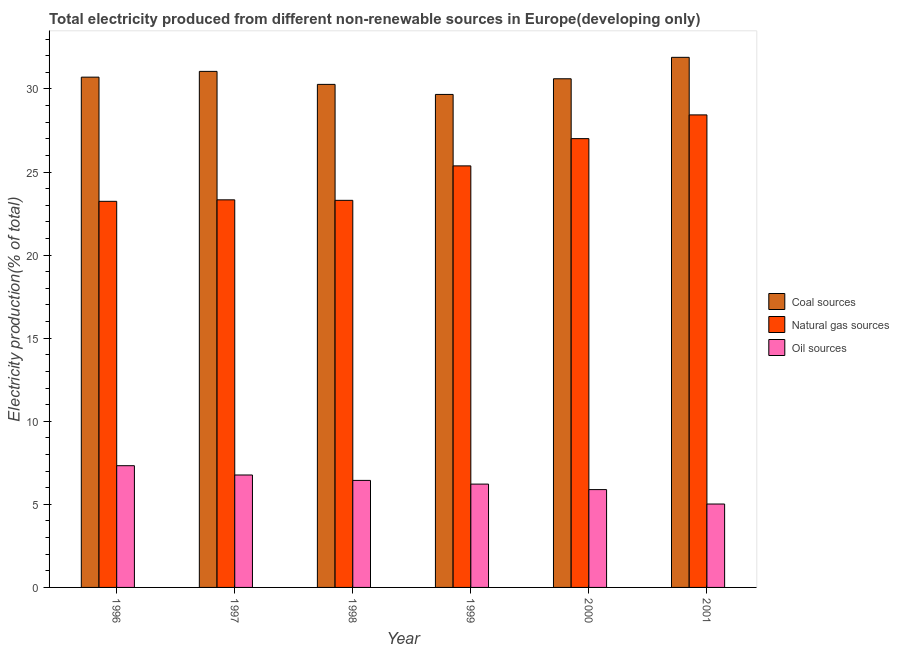How many groups of bars are there?
Your answer should be compact. 6. Are the number of bars on each tick of the X-axis equal?
Keep it short and to the point. Yes. How many bars are there on the 2nd tick from the left?
Provide a short and direct response. 3. How many bars are there on the 4th tick from the right?
Your answer should be compact. 3. What is the percentage of electricity produced by oil sources in 1998?
Your answer should be compact. 6.44. Across all years, what is the maximum percentage of electricity produced by coal?
Ensure brevity in your answer.  31.9. Across all years, what is the minimum percentage of electricity produced by coal?
Provide a succinct answer. 29.67. What is the total percentage of electricity produced by natural gas in the graph?
Your answer should be compact. 150.68. What is the difference between the percentage of electricity produced by oil sources in 1999 and that in 2001?
Your answer should be compact. 1.2. What is the difference between the percentage of electricity produced by coal in 2000 and the percentage of electricity produced by natural gas in 2001?
Offer a very short reply. -1.29. What is the average percentage of electricity produced by coal per year?
Keep it short and to the point. 30.71. In the year 2001, what is the difference between the percentage of electricity produced by coal and percentage of electricity produced by oil sources?
Make the answer very short. 0. In how many years, is the percentage of electricity produced by natural gas greater than 8 %?
Your answer should be very brief. 6. What is the ratio of the percentage of electricity produced by natural gas in 1998 to that in 1999?
Offer a terse response. 0.92. Is the percentage of electricity produced by coal in 1997 less than that in 1999?
Your answer should be compact. No. What is the difference between the highest and the second highest percentage of electricity produced by oil sources?
Your answer should be very brief. 0.56. What is the difference between the highest and the lowest percentage of electricity produced by coal?
Offer a very short reply. 2.23. In how many years, is the percentage of electricity produced by oil sources greater than the average percentage of electricity produced by oil sources taken over all years?
Offer a terse response. 3. Is the sum of the percentage of electricity produced by oil sources in 2000 and 2001 greater than the maximum percentage of electricity produced by natural gas across all years?
Keep it short and to the point. Yes. What does the 1st bar from the left in 1998 represents?
Offer a terse response. Coal sources. What does the 2nd bar from the right in 1999 represents?
Provide a short and direct response. Natural gas sources. Is it the case that in every year, the sum of the percentage of electricity produced by coal and percentage of electricity produced by natural gas is greater than the percentage of electricity produced by oil sources?
Make the answer very short. Yes. Are all the bars in the graph horizontal?
Provide a succinct answer. No. Does the graph contain any zero values?
Ensure brevity in your answer.  No. What is the title of the graph?
Give a very brief answer. Total electricity produced from different non-renewable sources in Europe(developing only). Does "ICT services" appear as one of the legend labels in the graph?
Your response must be concise. No. What is the label or title of the Y-axis?
Keep it short and to the point. Electricity production(% of total). What is the Electricity production(% of total) of Coal sources in 1996?
Your response must be concise. 30.71. What is the Electricity production(% of total) in Natural gas sources in 1996?
Your response must be concise. 23.24. What is the Electricity production(% of total) of Oil sources in 1996?
Ensure brevity in your answer.  7.33. What is the Electricity production(% of total) of Coal sources in 1997?
Ensure brevity in your answer.  31.06. What is the Electricity production(% of total) in Natural gas sources in 1997?
Provide a short and direct response. 23.33. What is the Electricity production(% of total) of Oil sources in 1997?
Give a very brief answer. 6.77. What is the Electricity production(% of total) of Coal sources in 1998?
Offer a very short reply. 30.28. What is the Electricity production(% of total) in Natural gas sources in 1998?
Keep it short and to the point. 23.3. What is the Electricity production(% of total) in Oil sources in 1998?
Ensure brevity in your answer.  6.44. What is the Electricity production(% of total) of Coal sources in 1999?
Make the answer very short. 29.67. What is the Electricity production(% of total) in Natural gas sources in 1999?
Give a very brief answer. 25.37. What is the Electricity production(% of total) in Oil sources in 1999?
Your answer should be very brief. 6.22. What is the Electricity production(% of total) of Coal sources in 2000?
Keep it short and to the point. 30.61. What is the Electricity production(% of total) in Natural gas sources in 2000?
Make the answer very short. 27.01. What is the Electricity production(% of total) of Oil sources in 2000?
Your response must be concise. 5.89. What is the Electricity production(% of total) in Coal sources in 2001?
Offer a very short reply. 31.9. What is the Electricity production(% of total) in Natural gas sources in 2001?
Keep it short and to the point. 28.44. What is the Electricity production(% of total) in Oil sources in 2001?
Your answer should be very brief. 5.02. Across all years, what is the maximum Electricity production(% of total) of Coal sources?
Provide a succinct answer. 31.9. Across all years, what is the maximum Electricity production(% of total) in Natural gas sources?
Provide a short and direct response. 28.44. Across all years, what is the maximum Electricity production(% of total) of Oil sources?
Ensure brevity in your answer.  7.33. Across all years, what is the minimum Electricity production(% of total) of Coal sources?
Give a very brief answer. 29.67. Across all years, what is the minimum Electricity production(% of total) of Natural gas sources?
Ensure brevity in your answer.  23.24. Across all years, what is the minimum Electricity production(% of total) of Oil sources?
Give a very brief answer. 5.02. What is the total Electricity production(% of total) of Coal sources in the graph?
Your answer should be compact. 184.23. What is the total Electricity production(% of total) in Natural gas sources in the graph?
Provide a short and direct response. 150.68. What is the total Electricity production(% of total) of Oil sources in the graph?
Offer a very short reply. 37.66. What is the difference between the Electricity production(% of total) in Coal sources in 1996 and that in 1997?
Make the answer very short. -0.35. What is the difference between the Electricity production(% of total) in Natural gas sources in 1996 and that in 1997?
Provide a short and direct response. -0.09. What is the difference between the Electricity production(% of total) of Oil sources in 1996 and that in 1997?
Your response must be concise. 0.56. What is the difference between the Electricity production(% of total) in Coal sources in 1996 and that in 1998?
Offer a very short reply. 0.44. What is the difference between the Electricity production(% of total) in Natural gas sources in 1996 and that in 1998?
Offer a very short reply. -0.06. What is the difference between the Electricity production(% of total) in Oil sources in 1996 and that in 1998?
Provide a short and direct response. 0.88. What is the difference between the Electricity production(% of total) of Coal sources in 1996 and that in 1999?
Your answer should be very brief. 1.04. What is the difference between the Electricity production(% of total) of Natural gas sources in 1996 and that in 1999?
Provide a succinct answer. -2.13. What is the difference between the Electricity production(% of total) in Oil sources in 1996 and that in 1999?
Give a very brief answer. 1.11. What is the difference between the Electricity production(% of total) of Coal sources in 1996 and that in 2000?
Your response must be concise. 0.1. What is the difference between the Electricity production(% of total) of Natural gas sources in 1996 and that in 2000?
Your answer should be very brief. -3.77. What is the difference between the Electricity production(% of total) in Oil sources in 1996 and that in 2000?
Your answer should be compact. 1.44. What is the difference between the Electricity production(% of total) in Coal sources in 1996 and that in 2001?
Offer a terse response. -1.19. What is the difference between the Electricity production(% of total) in Natural gas sources in 1996 and that in 2001?
Your response must be concise. -5.2. What is the difference between the Electricity production(% of total) of Oil sources in 1996 and that in 2001?
Your response must be concise. 2.31. What is the difference between the Electricity production(% of total) in Coal sources in 1997 and that in 1998?
Offer a terse response. 0.78. What is the difference between the Electricity production(% of total) of Natural gas sources in 1997 and that in 1998?
Your answer should be compact. 0.03. What is the difference between the Electricity production(% of total) of Oil sources in 1997 and that in 1998?
Give a very brief answer. 0.33. What is the difference between the Electricity production(% of total) in Coal sources in 1997 and that in 1999?
Provide a succinct answer. 1.39. What is the difference between the Electricity production(% of total) in Natural gas sources in 1997 and that in 1999?
Keep it short and to the point. -2.04. What is the difference between the Electricity production(% of total) in Oil sources in 1997 and that in 1999?
Ensure brevity in your answer.  0.55. What is the difference between the Electricity production(% of total) of Coal sources in 1997 and that in 2000?
Your response must be concise. 0.45. What is the difference between the Electricity production(% of total) in Natural gas sources in 1997 and that in 2000?
Ensure brevity in your answer.  -3.68. What is the difference between the Electricity production(% of total) of Coal sources in 1997 and that in 2001?
Your response must be concise. -0.85. What is the difference between the Electricity production(% of total) in Natural gas sources in 1997 and that in 2001?
Give a very brief answer. -5.11. What is the difference between the Electricity production(% of total) in Oil sources in 1997 and that in 2001?
Provide a short and direct response. 1.75. What is the difference between the Electricity production(% of total) of Coal sources in 1998 and that in 1999?
Your answer should be very brief. 0.61. What is the difference between the Electricity production(% of total) of Natural gas sources in 1998 and that in 1999?
Your answer should be compact. -2.07. What is the difference between the Electricity production(% of total) in Oil sources in 1998 and that in 1999?
Offer a terse response. 0.22. What is the difference between the Electricity production(% of total) in Coal sources in 1998 and that in 2000?
Keep it short and to the point. -0.34. What is the difference between the Electricity production(% of total) of Natural gas sources in 1998 and that in 2000?
Your response must be concise. -3.71. What is the difference between the Electricity production(% of total) in Oil sources in 1998 and that in 2000?
Offer a very short reply. 0.55. What is the difference between the Electricity production(% of total) of Coal sources in 1998 and that in 2001?
Provide a short and direct response. -1.63. What is the difference between the Electricity production(% of total) of Natural gas sources in 1998 and that in 2001?
Make the answer very short. -5.14. What is the difference between the Electricity production(% of total) in Oil sources in 1998 and that in 2001?
Offer a terse response. 1.42. What is the difference between the Electricity production(% of total) in Coal sources in 1999 and that in 2000?
Your response must be concise. -0.94. What is the difference between the Electricity production(% of total) in Natural gas sources in 1999 and that in 2000?
Your response must be concise. -1.64. What is the difference between the Electricity production(% of total) in Oil sources in 1999 and that in 2000?
Offer a very short reply. 0.33. What is the difference between the Electricity production(% of total) of Coal sources in 1999 and that in 2001?
Provide a succinct answer. -2.23. What is the difference between the Electricity production(% of total) in Natural gas sources in 1999 and that in 2001?
Give a very brief answer. -3.07. What is the difference between the Electricity production(% of total) in Oil sources in 1999 and that in 2001?
Offer a terse response. 1.2. What is the difference between the Electricity production(% of total) in Coal sources in 2000 and that in 2001?
Offer a terse response. -1.29. What is the difference between the Electricity production(% of total) in Natural gas sources in 2000 and that in 2001?
Provide a short and direct response. -1.43. What is the difference between the Electricity production(% of total) in Oil sources in 2000 and that in 2001?
Ensure brevity in your answer.  0.87. What is the difference between the Electricity production(% of total) of Coal sources in 1996 and the Electricity production(% of total) of Natural gas sources in 1997?
Offer a terse response. 7.38. What is the difference between the Electricity production(% of total) of Coal sources in 1996 and the Electricity production(% of total) of Oil sources in 1997?
Your response must be concise. 23.94. What is the difference between the Electricity production(% of total) in Natural gas sources in 1996 and the Electricity production(% of total) in Oil sources in 1997?
Provide a succinct answer. 16.47. What is the difference between the Electricity production(% of total) in Coal sources in 1996 and the Electricity production(% of total) in Natural gas sources in 1998?
Ensure brevity in your answer.  7.41. What is the difference between the Electricity production(% of total) in Coal sources in 1996 and the Electricity production(% of total) in Oil sources in 1998?
Offer a very short reply. 24.27. What is the difference between the Electricity production(% of total) of Natural gas sources in 1996 and the Electricity production(% of total) of Oil sources in 1998?
Your response must be concise. 16.8. What is the difference between the Electricity production(% of total) of Coal sources in 1996 and the Electricity production(% of total) of Natural gas sources in 1999?
Give a very brief answer. 5.34. What is the difference between the Electricity production(% of total) of Coal sources in 1996 and the Electricity production(% of total) of Oil sources in 1999?
Offer a very short reply. 24.49. What is the difference between the Electricity production(% of total) in Natural gas sources in 1996 and the Electricity production(% of total) in Oil sources in 1999?
Your response must be concise. 17.02. What is the difference between the Electricity production(% of total) in Coal sources in 1996 and the Electricity production(% of total) in Natural gas sources in 2000?
Ensure brevity in your answer.  3.7. What is the difference between the Electricity production(% of total) of Coal sources in 1996 and the Electricity production(% of total) of Oil sources in 2000?
Give a very brief answer. 24.82. What is the difference between the Electricity production(% of total) in Natural gas sources in 1996 and the Electricity production(% of total) in Oil sources in 2000?
Provide a succinct answer. 17.35. What is the difference between the Electricity production(% of total) of Coal sources in 1996 and the Electricity production(% of total) of Natural gas sources in 2001?
Your response must be concise. 2.27. What is the difference between the Electricity production(% of total) in Coal sources in 1996 and the Electricity production(% of total) in Oil sources in 2001?
Give a very brief answer. 25.69. What is the difference between the Electricity production(% of total) of Natural gas sources in 1996 and the Electricity production(% of total) of Oil sources in 2001?
Keep it short and to the point. 18.22. What is the difference between the Electricity production(% of total) of Coal sources in 1997 and the Electricity production(% of total) of Natural gas sources in 1998?
Offer a terse response. 7.76. What is the difference between the Electricity production(% of total) in Coal sources in 1997 and the Electricity production(% of total) in Oil sources in 1998?
Your response must be concise. 24.62. What is the difference between the Electricity production(% of total) of Natural gas sources in 1997 and the Electricity production(% of total) of Oil sources in 1998?
Your response must be concise. 16.89. What is the difference between the Electricity production(% of total) in Coal sources in 1997 and the Electricity production(% of total) in Natural gas sources in 1999?
Provide a short and direct response. 5.69. What is the difference between the Electricity production(% of total) in Coal sources in 1997 and the Electricity production(% of total) in Oil sources in 1999?
Offer a terse response. 24.84. What is the difference between the Electricity production(% of total) in Natural gas sources in 1997 and the Electricity production(% of total) in Oil sources in 1999?
Your answer should be compact. 17.11. What is the difference between the Electricity production(% of total) in Coal sources in 1997 and the Electricity production(% of total) in Natural gas sources in 2000?
Provide a succinct answer. 4.05. What is the difference between the Electricity production(% of total) of Coal sources in 1997 and the Electricity production(% of total) of Oil sources in 2000?
Your answer should be compact. 25.17. What is the difference between the Electricity production(% of total) of Natural gas sources in 1997 and the Electricity production(% of total) of Oil sources in 2000?
Give a very brief answer. 17.44. What is the difference between the Electricity production(% of total) in Coal sources in 1997 and the Electricity production(% of total) in Natural gas sources in 2001?
Offer a very short reply. 2.62. What is the difference between the Electricity production(% of total) in Coal sources in 1997 and the Electricity production(% of total) in Oil sources in 2001?
Your answer should be very brief. 26.04. What is the difference between the Electricity production(% of total) in Natural gas sources in 1997 and the Electricity production(% of total) in Oil sources in 2001?
Your answer should be compact. 18.31. What is the difference between the Electricity production(% of total) of Coal sources in 1998 and the Electricity production(% of total) of Natural gas sources in 1999?
Ensure brevity in your answer.  4.9. What is the difference between the Electricity production(% of total) in Coal sources in 1998 and the Electricity production(% of total) in Oil sources in 1999?
Your response must be concise. 24.06. What is the difference between the Electricity production(% of total) in Natural gas sources in 1998 and the Electricity production(% of total) in Oil sources in 1999?
Your answer should be very brief. 17.08. What is the difference between the Electricity production(% of total) in Coal sources in 1998 and the Electricity production(% of total) in Natural gas sources in 2000?
Your answer should be very brief. 3.27. What is the difference between the Electricity production(% of total) of Coal sources in 1998 and the Electricity production(% of total) of Oil sources in 2000?
Offer a terse response. 24.39. What is the difference between the Electricity production(% of total) of Natural gas sources in 1998 and the Electricity production(% of total) of Oil sources in 2000?
Make the answer very short. 17.41. What is the difference between the Electricity production(% of total) of Coal sources in 1998 and the Electricity production(% of total) of Natural gas sources in 2001?
Keep it short and to the point. 1.84. What is the difference between the Electricity production(% of total) in Coal sources in 1998 and the Electricity production(% of total) in Oil sources in 2001?
Ensure brevity in your answer.  25.26. What is the difference between the Electricity production(% of total) in Natural gas sources in 1998 and the Electricity production(% of total) in Oil sources in 2001?
Make the answer very short. 18.28. What is the difference between the Electricity production(% of total) in Coal sources in 1999 and the Electricity production(% of total) in Natural gas sources in 2000?
Your answer should be compact. 2.66. What is the difference between the Electricity production(% of total) of Coal sources in 1999 and the Electricity production(% of total) of Oil sources in 2000?
Give a very brief answer. 23.78. What is the difference between the Electricity production(% of total) in Natural gas sources in 1999 and the Electricity production(% of total) in Oil sources in 2000?
Ensure brevity in your answer.  19.48. What is the difference between the Electricity production(% of total) in Coal sources in 1999 and the Electricity production(% of total) in Natural gas sources in 2001?
Your response must be concise. 1.23. What is the difference between the Electricity production(% of total) of Coal sources in 1999 and the Electricity production(% of total) of Oil sources in 2001?
Offer a very short reply. 24.65. What is the difference between the Electricity production(% of total) in Natural gas sources in 1999 and the Electricity production(% of total) in Oil sources in 2001?
Your response must be concise. 20.35. What is the difference between the Electricity production(% of total) in Coal sources in 2000 and the Electricity production(% of total) in Natural gas sources in 2001?
Your answer should be very brief. 2.17. What is the difference between the Electricity production(% of total) in Coal sources in 2000 and the Electricity production(% of total) in Oil sources in 2001?
Your answer should be compact. 25.59. What is the difference between the Electricity production(% of total) of Natural gas sources in 2000 and the Electricity production(% of total) of Oil sources in 2001?
Give a very brief answer. 21.99. What is the average Electricity production(% of total) of Coal sources per year?
Your answer should be very brief. 30.71. What is the average Electricity production(% of total) in Natural gas sources per year?
Your response must be concise. 25.11. What is the average Electricity production(% of total) in Oil sources per year?
Your answer should be very brief. 6.28. In the year 1996, what is the difference between the Electricity production(% of total) in Coal sources and Electricity production(% of total) in Natural gas sources?
Provide a short and direct response. 7.47. In the year 1996, what is the difference between the Electricity production(% of total) in Coal sources and Electricity production(% of total) in Oil sources?
Make the answer very short. 23.39. In the year 1996, what is the difference between the Electricity production(% of total) of Natural gas sources and Electricity production(% of total) of Oil sources?
Offer a very short reply. 15.91. In the year 1997, what is the difference between the Electricity production(% of total) of Coal sources and Electricity production(% of total) of Natural gas sources?
Your response must be concise. 7.73. In the year 1997, what is the difference between the Electricity production(% of total) of Coal sources and Electricity production(% of total) of Oil sources?
Provide a succinct answer. 24.29. In the year 1997, what is the difference between the Electricity production(% of total) in Natural gas sources and Electricity production(% of total) in Oil sources?
Provide a short and direct response. 16.56. In the year 1998, what is the difference between the Electricity production(% of total) of Coal sources and Electricity production(% of total) of Natural gas sources?
Give a very brief answer. 6.98. In the year 1998, what is the difference between the Electricity production(% of total) of Coal sources and Electricity production(% of total) of Oil sources?
Make the answer very short. 23.83. In the year 1998, what is the difference between the Electricity production(% of total) in Natural gas sources and Electricity production(% of total) in Oil sources?
Your response must be concise. 16.86. In the year 1999, what is the difference between the Electricity production(% of total) of Coal sources and Electricity production(% of total) of Natural gas sources?
Provide a succinct answer. 4.3. In the year 1999, what is the difference between the Electricity production(% of total) in Coal sources and Electricity production(% of total) in Oil sources?
Provide a short and direct response. 23.45. In the year 1999, what is the difference between the Electricity production(% of total) of Natural gas sources and Electricity production(% of total) of Oil sources?
Offer a very short reply. 19.15. In the year 2000, what is the difference between the Electricity production(% of total) in Coal sources and Electricity production(% of total) in Natural gas sources?
Make the answer very short. 3.6. In the year 2000, what is the difference between the Electricity production(% of total) of Coal sources and Electricity production(% of total) of Oil sources?
Your answer should be very brief. 24.73. In the year 2000, what is the difference between the Electricity production(% of total) in Natural gas sources and Electricity production(% of total) in Oil sources?
Offer a terse response. 21.12. In the year 2001, what is the difference between the Electricity production(% of total) in Coal sources and Electricity production(% of total) in Natural gas sources?
Your response must be concise. 3.46. In the year 2001, what is the difference between the Electricity production(% of total) in Coal sources and Electricity production(% of total) in Oil sources?
Ensure brevity in your answer.  26.88. In the year 2001, what is the difference between the Electricity production(% of total) in Natural gas sources and Electricity production(% of total) in Oil sources?
Your answer should be compact. 23.42. What is the ratio of the Electricity production(% of total) of Natural gas sources in 1996 to that in 1997?
Offer a very short reply. 1. What is the ratio of the Electricity production(% of total) of Oil sources in 1996 to that in 1997?
Offer a very short reply. 1.08. What is the ratio of the Electricity production(% of total) of Coal sources in 1996 to that in 1998?
Offer a terse response. 1.01. What is the ratio of the Electricity production(% of total) of Natural gas sources in 1996 to that in 1998?
Your answer should be very brief. 1. What is the ratio of the Electricity production(% of total) of Oil sources in 1996 to that in 1998?
Your answer should be compact. 1.14. What is the ratio of the Electricity production(% of total) of Coal sources in 1996 to that in 1999?
Give a very brief answer. 1.04. What is the ratio of the Electricity production(% of total) of Natural gas sources in 1996 to that in 1999?
Your answer should be very brief. 0.92. What is the ratio of the Electricity production(% of total) of Oil sources in 1996 to that in 1999?
Ensure brevity in your answer.  1.18. What is the ratio of the Electricity production(% of total) in Natural gas sources in 1996 to that in 2000?
Make the answer very short. 0.86. What is the ratio of the Electricity production(% of total) of Oil sources in 1996 to that in 2000?
Make the answer very short. 1.24. What is the ratio of the Electricity production(% of total) in Coal sources in 1996 to that in 2001?
Offer a very short reply. 0.96. What is the ratio of the Electricity production(% of total) in Natural gas sources in 1996 to that in 2001?
Your answer should be very brief. 0.82. What is the ratio of the Electricity production(% of total) in Oil sources in 1996 to that in 2001?
Make the answer very short. 1.46. What is the ratio of the Electricity production(% of total) of Coal sources in 1997 to that in 1998?
Offer a very short reply. 1.03. What is the ratio of the Electricity production(% of total) in Natural gas sources in 1997 to that in 1998?
Make the answer very short. 1. What is the ratio of the Electricity production(% of total) of Oil sources in 1997 to that in 1998?
Your answer should be compact. 1.05. What is the ratio of the Electricity production(% of total) in Coal sources in 1997 to that in 1999?
Provide a short and direct response. 1.05. What is the ratio of the Electricity production(% of total) in Natural gas sources in 1997 to that in 1999?
Offer a terse response. 0.92. What is the ratio of the Electricity production(% of total) of Oil sources in 1997 to that in 1999?
Provide a succinct answer. 1.09. What is the ratio of the Electricity production(% of total) of Coal sources in 1997 to that in 2000?
Your response must be concise. 1.01. What is the ratio of the Electricity production(% of total) of Natural gas sources in 1997 to that in 2000?
Offer a terse response. 0.86. What is the ratio of the Electricity production(% of total) of Oil sources in 1997 to that in 2000?
Make the answer very short. 1.15. What is the ratio of the Electricity production(% of total) of Coal sources in 1997 to that in 2001?
Your answer should be compact. 0.97. What is the ratio of the Electricity production(% of total) in Natural gas sources in 1997 to that in 2001?
Your response must be concise. 0.82. What is the ratio of the Electricity production(% of total) in Oil sources in 1997 to that in 2001?
Offer a very short reply. 1.35. What is the ratio of the Electricity production(% of total) of Coal sources in 1998 to that in 1999?
Your answer should be very brief. 1.02. What is the ratio of the Electricity production(% of total) of Natural gas sources in 1998 to that in 1999?
Provide a short and direct response. 0.92. What is the ratio of the Electricity production(% of total) in Oil sources in 1998 to that in 1999?
Make the answer very short. 1.04. What is the ratio of the Electricity production(% of total) in Natural gas sources in 1998 to that in 2000?
Give a very brief answer. 0.86. What is the ratio of the Electricity production(% of total) in Oil sources in 1998 to that in 2000?
Your response must be concise. 1.09. What is the ratio of the Electricity production(% of total) of Coal sources in 1998 to that in 2001?
Your response must be concise. 0.95. What is the ratio of the Electricity production(% of total) in Natural gas sources in 1998 to that in 2001?
Provide a short and direct response. 0.82. What is the ratio of the Electricity production(% of total) in Oil sources in 1998 to that in 2001?
Your response must be concise. 1.28. What is the ratio of the Electricity production(% of total) of Coal sources in 1999 to that in 2000?
Your answer should be very brief. 0.97. What is the ratio of the Electricity production(% of total) in Natural gas sources in 1999 to that in 2000?
Offer a terse response. 0.94. What is the ratio of the Electricity production(% of total) in Oil sources in 1999 to that in 2000?
Your response must be concise. 1.06. What is the ratio of the Electricity production(% of total) of Coal sources in 1999 to that in 2001?
Keep it short and to the point. 0.93. What is the ratio of the Electricity production(% of total) in Natural gas sources in 1999 to that in 2001?
Provide a succinct answer. 0.89. What is the ratio of the Electricity production(% of total) of Oil sources in 1999 to that in 2001?
Provide a succinct answer. 1.24. What is the ratio of the Electricity production(% of total) of Coal sources in 2000 to that in 2001?
Ensure brevity in your answer.  0.96. What is the ratio of the Electricity production(% of total) in Natural gas sources in 2000 to that in 2001?
Your answer should be compact. 0.95. What is the ratio of the Electricity production(% of total) in Oil sources in 2000 to that in 2001?
Keep it short and to the point. 1.17. What is the difference between the highest and the second highest Electricity production(% of total) of Coal sources?
Give a very brief answer. 0.85. What is the difference between the highest and the second highest Electricity production(% of total) in Natural gas sources?
Your answer should be compact. 1.43. What is the difference between the highest and the second highest Electricity production(% of total) of Oil sources?
Offer a very short reply. 0.56. What is the difference between the highest and the lowest Electricity production(% of total) of Coal sources?
Give a very brief answer. 2.23. What is the difference between the highest and the lowest Electricity production(% of total) in Natural gas sources?
Offer a terse response. 5.2. What is the difference between the highest and the lowest Electricity production(% of total) in Oil sources?
Make the answer very short. 2.31. 